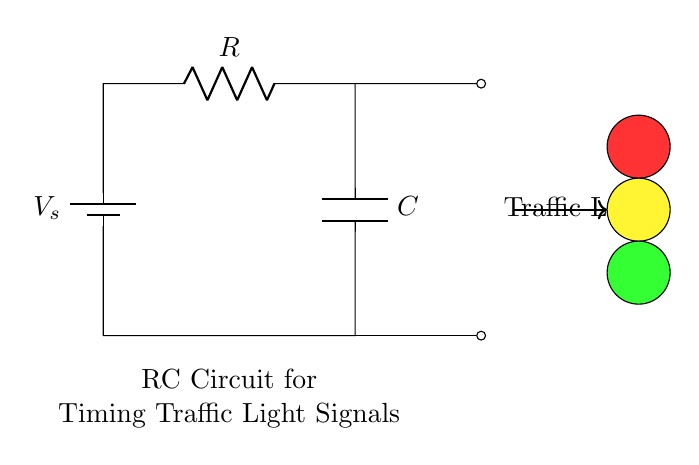What is the total voltage supplied by the battery? The total voltage supplied by the battery is marked as V_s in the diagram. This represents the source voltage in the circuit.
Answer: V_s What components are present in the circuit? The circuit consists of three main components: a battery, a resistor, and a capacitor, as denoted in the diagram.
Answer: Battery, Resistor, Capacitor What role does the capacitor play in this circuit? The capacitor stores electrical energy, and in timing circuits, it regulates the timing by charging and discharging over time, affecting how long the traffic light stays in each color.
Answer: Timing What happens to the voltage across the capacitor as time passes? As time passes, the voltage across the capacitor increases until it reaches the source voltage V_s, then it discharges and the cycle repeats, creating a timing function for the traffic light.
Answer: Increases What is the relationship between resistance and time delay in this circuit? The resistance value (R) in an RC circuit dictates how quickly the capacitor charges and discharges; higher resistance values result in longer time delays for the timing function.
Answer: Increases delay What is the purpose of the traffic light in this circuit? The traffic light transmits the signals for traffic control, changing colors based on the timing managed by the RC circuit, ensuring safe traffic flow.
Answer: Traffic control 